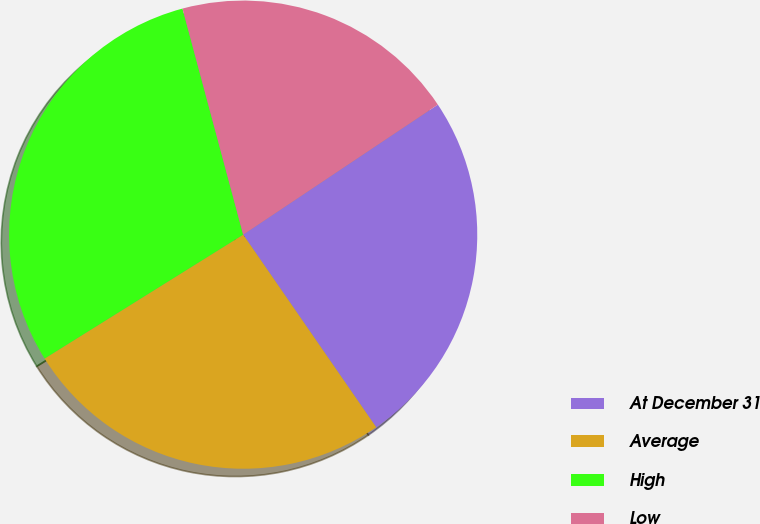Convert chart to OTSL. <chart><loc_0><loc_0><loc_500><loc_500><pie_chart><fcel>At December 31<fcel>Average<fcel>High<fcel>Low<nl><fcel>24.75%<fcel>25.74%<fcel>29.7%<fcel>19.8%<nl></chart> 